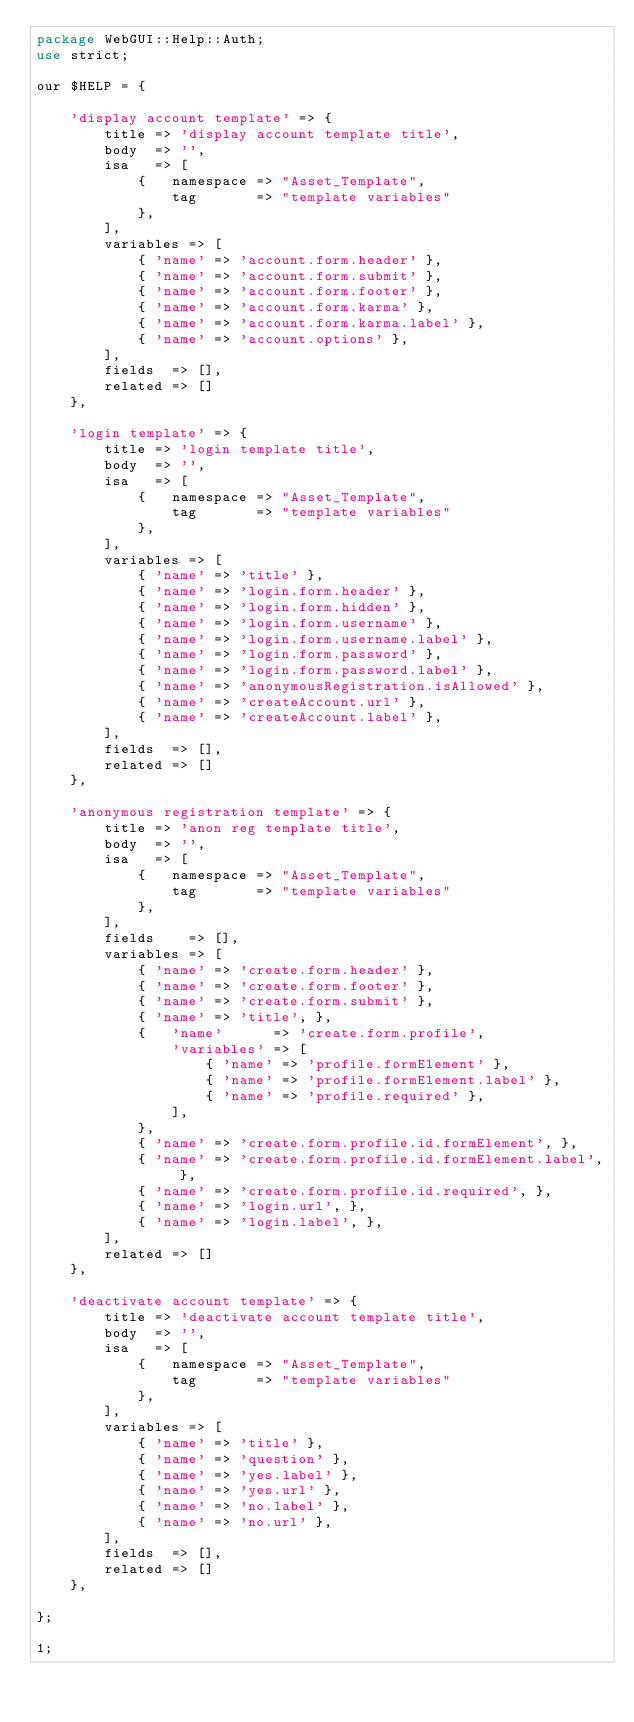Convert code to text. <code><loc_0><loc_0><loc_500><loc_500><_Perl_>package WebGUI::Help::Auth;
use strict;

our $HELP = {

    'display account template' => {
        title => 'display account template title',
        body  => '',
        isa   => [
            {   namespace => "Asset_Template",
                tag       => "template variables"
            },
        ],
        variables => [
            { 'name' => 'account.form.header' },
            { 'name' => 'account.form.submit' },
            { 'name' => 'account.form.footer' },
            { 'name' => 'account.form.karma' },
            { 'name' => 'account.form.karma.label' },
            { 'name' => 'account.options' },
        ],
        fields  => [],
        related => []
    },

    'login template' => {
        title => 'login template title',
        body  => '',
        isa   => [
            {   namespace => "Asset_Template",
                tag       => "template variables"
            },
        ],
        variables => [
            { 'name' => 'title' },
            { 'name' => 'login.form.header' },
            { 'name' => 'login.form.hidden' },
            { 'name' => 'login.form.username' },
            { 'name' => 'login.form.username.label' },
            { 'name' => 'login.form.password' },
            { 'name' => 'login.form.password.label' },
            { 'name' => 'anonymousRegistration.isAllowed' },
            { 'name' => 'createAccount.url' },
            { 'name' => 'createAccount.label' },
        ],
        fields  => [],
        related => []
    },

    'anonymous registration template' => {
        title => 'anon reg template title',
        body  => '',
        isa   => [
            {   namespace => "Asset_Template",
                tag       => "template variables"
            },
        ],
        fields    => [],
        variables => [
            { 'name' => 'create.form.header' },
            { 'name' => 'create.form.footer' },
            { 'name' => 'create.form.submit' },
            { 'name' => 'title', },
            {   'name'      => 'create.form.profile',
                'variables' => [
                    { 'name' => 'profile.formElement' },
                    { 'name' => 'profile.formElement.label' },
                    { 'name' => 'profile.required' },
                ],
            },
            { 'name' => 'create.form.profile.id.formElement', },
            { 'name' => 'create.form.profile.id.formElement.label', },
            { 'name' => 'create.form.profile.id.required', },
            { 'name' => 'login.url', },
            { 'name' => 'login.label', },
        ],
        related => []
    },

    'deactivate account template' => {
        title => 'deactivate account template title',
        body  => '',
        isa   => [
            {   namespace => "Asset_Template",
                tag       => "template variables"
            },
        ],
        variables => [
            { 'name' => 'title' },
            { 'name' => 'question' },
            { 'name' => 'yes.label' },
            { 'name' => 'yes.url' },
            { 'name' => 'no.label' },
            { 'name' => 'no.url' },
        ],
        fields  => [],
        related => []
    },

};

1;
</code> 